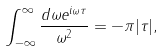Convert formula to latex. <formula><loc_0><loc_0><loc_500><loc_500>\int _ { - \infty } ^ { \infty } \frac { d \omega e ^ { i \omega \tau } } { \omega ^ { 2 } } = - \pi | \tau | ,</formula> 